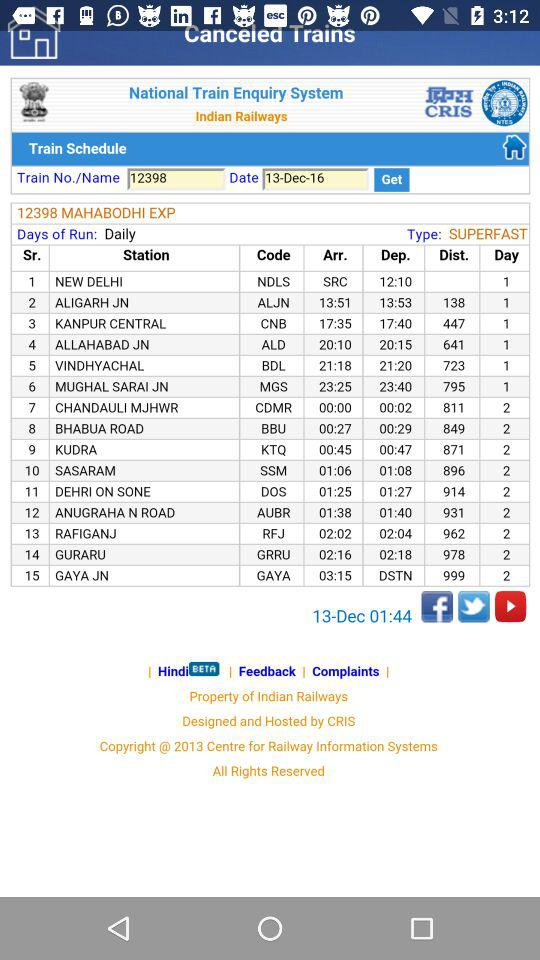What is the application name? The application name is "National Train Enquiry System". 